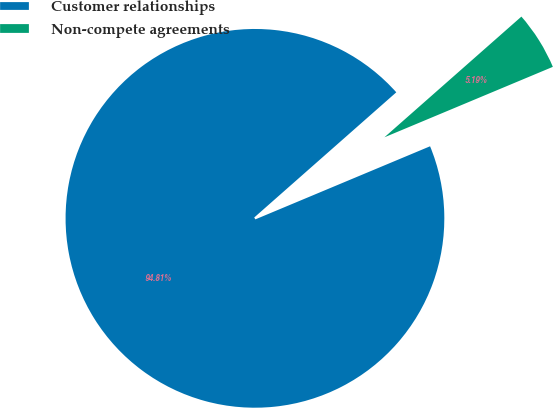<chart> <loc_0><loc_0><loc_500><loc_500><pie_chart><fcel>Customer relationships<fcel>Non-compete agreements<nl><fcel>94.81%<fcel>5.19%<nl></chart> 